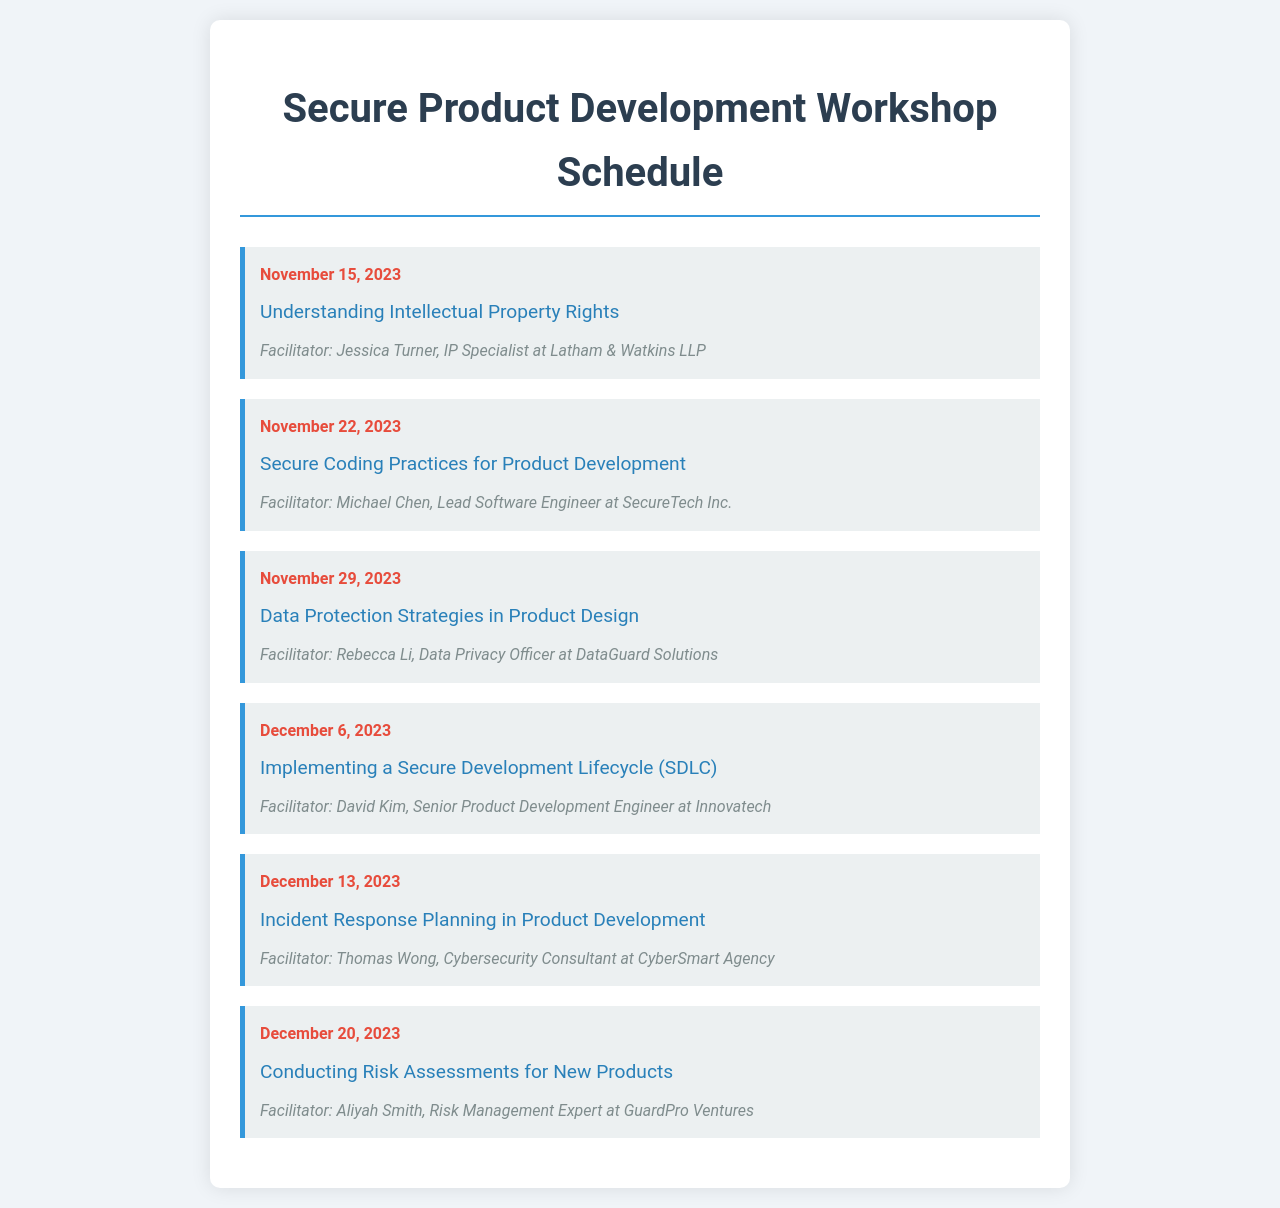what is the date of the first workshop? The date of the first workshop is provided in the document, which states "November 15, 2023."
Answer: November 15, 2023 who is the facilitator for the workshop on Secure Coding Practices? The document lists Michael Chen as the facilitator for the workshop on Secure Coding Practices taking place on November 22, 2023.
Answer: Michael Chen how many workshops are scheduled in total? The document outlines six workshops scheduled from November to December, providing the exact count.
Answer: Six what is the topic of the workshop on December 6, 2023? The schedule specifies "Implementing a Secure Development Lifecycle (SDLC" as the topic for that date.
Answer: Implementing a Secure Development Lifecycle (SDLC) which facilitator specializes in data privacy? The document identifies Rebecca Li as the Data Privacy Officer, facilitating the workshop on Data Protection Strategies.
Answer: Rebecca Li what topic is addressed on November 29, 2023? According to the schedule, "Data Protection Strategies in Product Design" is the topic for that workshop.
Answer: Data Protection Strategies in Product Design who facilitates the last workshop in December? The document indicates Aliyah Smith as the facilitator for the last workshop scheduled on December 20, 2023.
Answer: Aliyah Smith which workshop focuses on incident response planning? The workshop scheduled on December 13, 2023, is dedicated to incident response planning as stated in the document.
Answer: Incident Response Planning in Product Development 